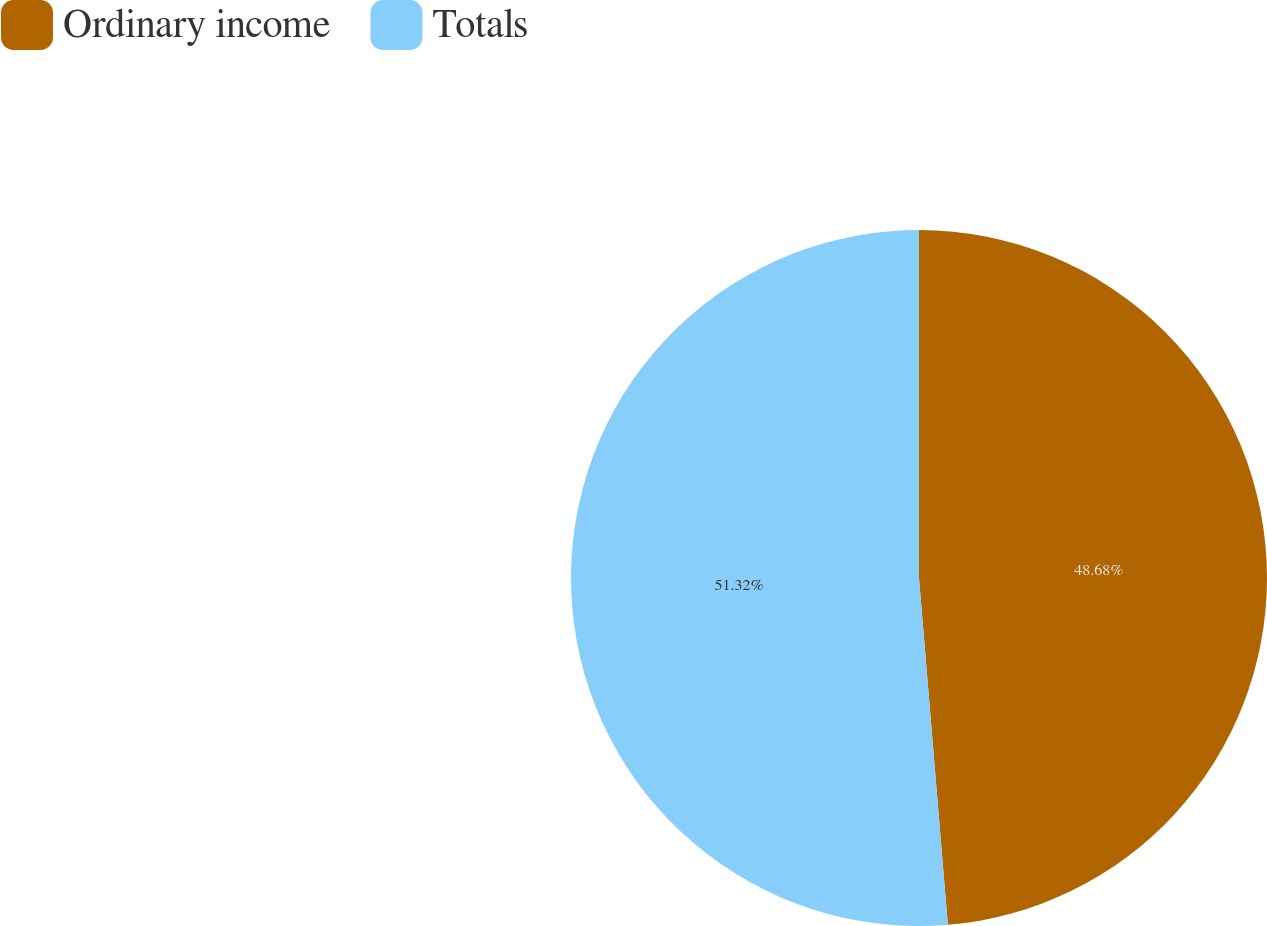<chart> <loc_0><loc_0><loc_500><loc_500><pie_chart><fcel>Ordinary income<fcel>Totals<nl><fcel>48.68%<fcel>51.32%<nl></chart> 